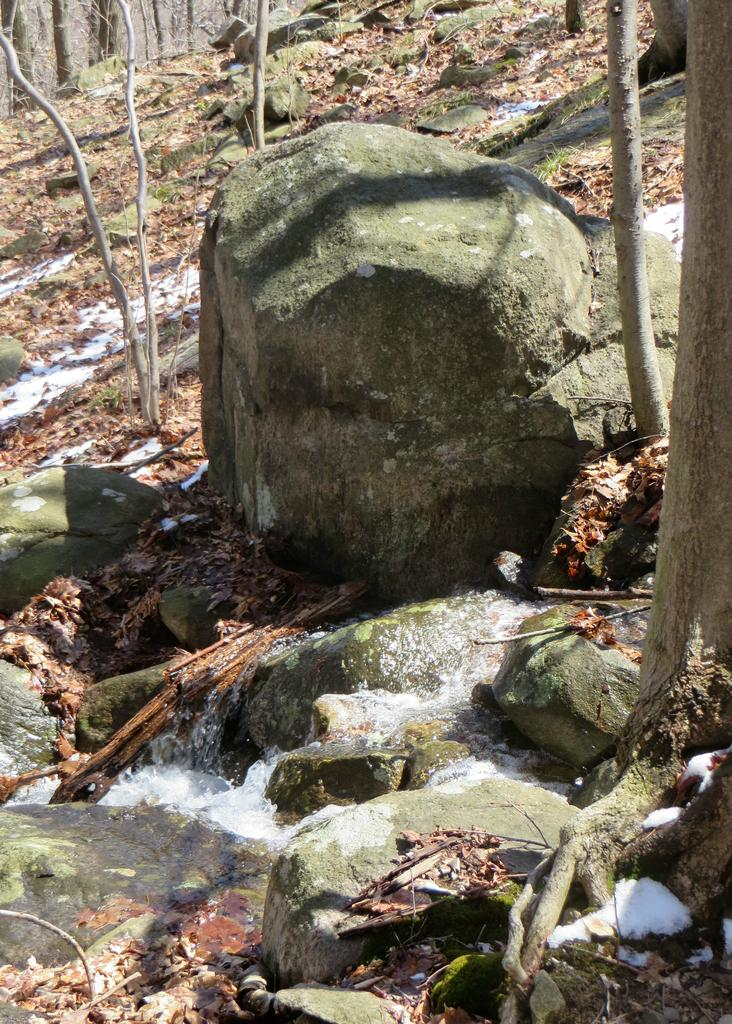Where was the image taken? The image is taken outdoors. What can be seen on the ground in the image? There are many dry leaves and running water on the ground in the image. What type of natural features are present in the image? There are rocks, trees, and plants in the image. What is the number of dresses worn by the country in the image? There is no country or dress present in the image. 